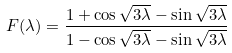<formula> <loc_0><loc_0><loc_500><loc_500>F ( \lambda ) = \frac { 1 + \cos \sqrt { 3 \lambda } - \sin \sqrt { 3 \lambda } } { 1 - \cos \sqrt { 3 \lambda } - \sin \sqrt { 3 \lambda } }</formula> 